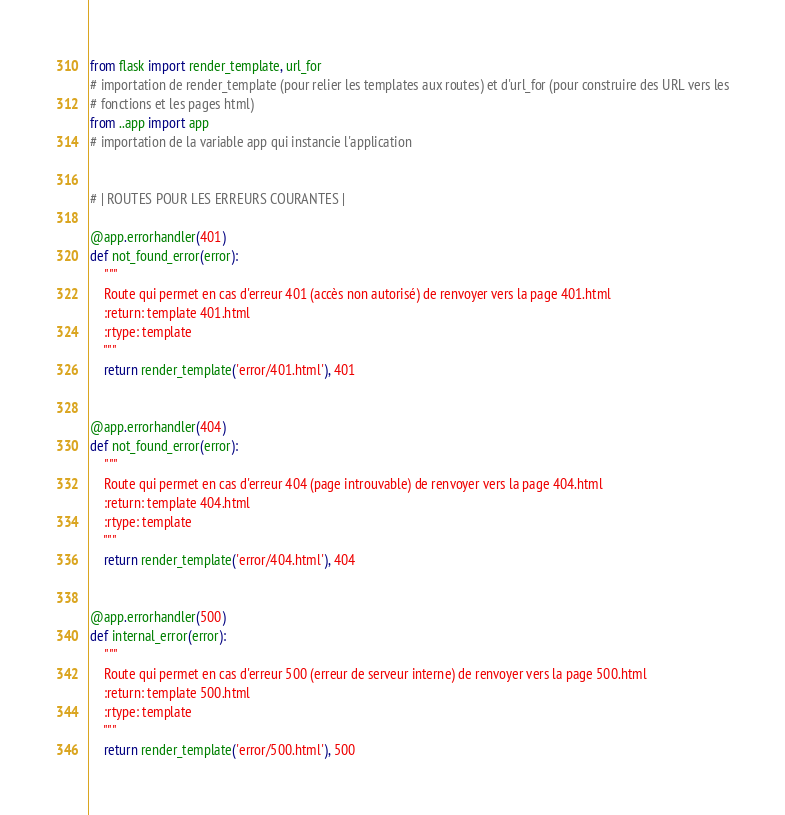Convert code to text. <code><loc_0><loc_0><loc_500><loc_500><_Python_>from flask import render_template, url_for
# importation de render_template (pour relier les templates aux routes) et d'url_for (pour construire des URL vers les
# fonctions et les pages html)
from ..app import app
# importation de la variable app qui instancie l'application


# | ROUTES POUR LES ERREURS COURANTES |

@app.errorhandler(401)
def not_found_error(error):
    """
    Route qui permet en cas d'erreur 401 (accès non autorisé) de renvoyer vers la page 401.html
    :return: template 401.html
    :rtype: template
    """
    return render_template('error/401.html'), 401


@app.errorhandler(404)
def not_found_error(error):
    """
    Route qui permet en cas d'erreur 404 (page introuvable) de renvoyer vers la page 404.html
    :return: template 404.html
    :rtype: template
    """
    return render_template('error/404.html'), 404


@app.errorhandler(500)
def internal_error(error):
    """
    Route qui permet en cas d'erreur 500 (erreur de serveur interne) de renvoyer vers la page 500.html
    :return: template 500.html
    :rtype: template
    """
    return render_template('error/500.html'), 500
</code> 